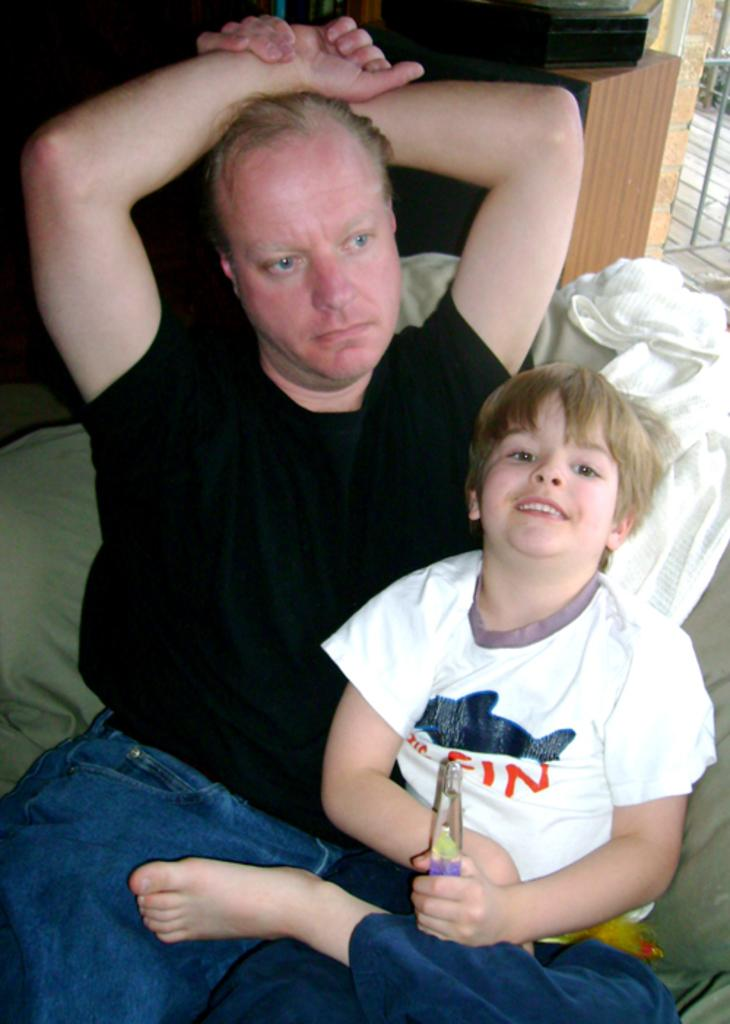What are the people in the image doing? There are people sitting on a sofa in the image. What is one of the people holding? One of the people is holding an object. Can you describe the object on a stand in the background of the image? There is an object on a stand in the background of the image. What architectural feature can be seen in the background of the image? A railing is visible in the background of the image. What type of pan is being used to ring the bells in the image? There is no pan or bells present in the image. What invention is being demonstrated by the people in the image? There is no invention being demonstrated by the people in the image; they are simply sitting on a sofa. 